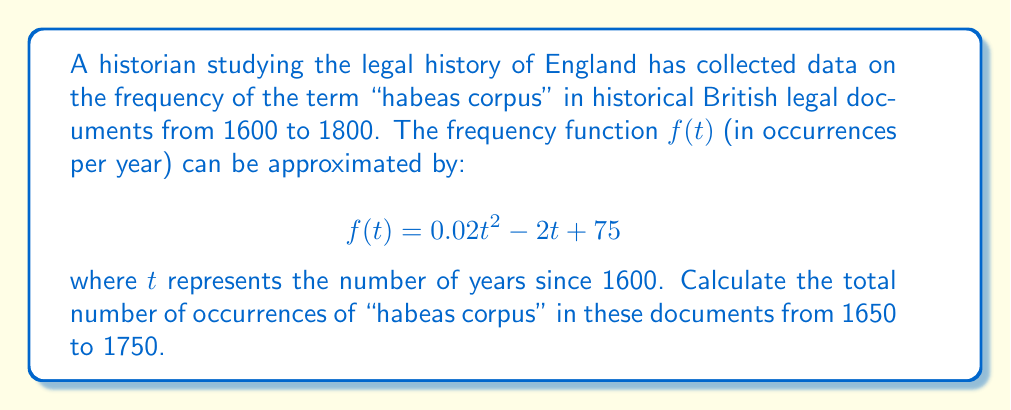What is the answer to this math problem? To solve this problem, we need to calculate the area under the curve $f(t)$ from $t=50$ (representing 1650) to $t=150$ (representing 1750). This can be done using a definite integral:

1) Set up the integral:
   $$\int_{50}^{150} (0.02t^2 - 2t + 75) \, dt$$

2) Integrate the function:
   $$\Big[\frac{0.02t^3}{3} - t^2 + 75t\Big]_{50}^{150}$$

3) Evaluate the integral:
   $$\Big(\frac{0.02(150)^3}{3} - (150)^2 + 75(150)\Big) - \Big(\frac{0.02(50)^3}{3} - (50)^2 + 75(50)\Big)$$

4) Calculate:
   $$(15000 - 22500 + 11250) - (833.33 - 2500 + 3750)$$
   $$= 3750 - 2083.33$$
   $$= 1666.67$$

The result represents the total number of occurrences over the 100-year period.
Answer: 1667 occurrences (rounded to nearest whole number) 